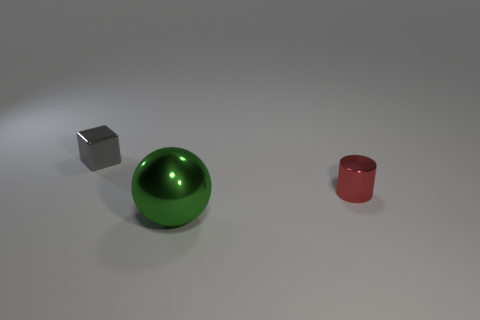If you had to guess, what materials do you think these objects are made from? The cube appears to be made of a brushed metal due to its matte finish and the way it reflects light. The green sphere's high gloss indicates that it could be made of polished glass or a reflective plastic. The red cylinder seems to have a slightly matte finish as well, suggesting a ceramic or powdered metal construction.  How might the presence of these objects affect the acoustics of the room? The objects in the image likely have a minimal effect on the room's acoustics. Their smooth surfaces may reflect sound, but due to their small size relative to a typical room, the impact would be negligible. If the room is otherwise empty and these objects are the only surfaces, the sound might be slightly crisper with subtle echoes bouncing off the hard surfaces. 